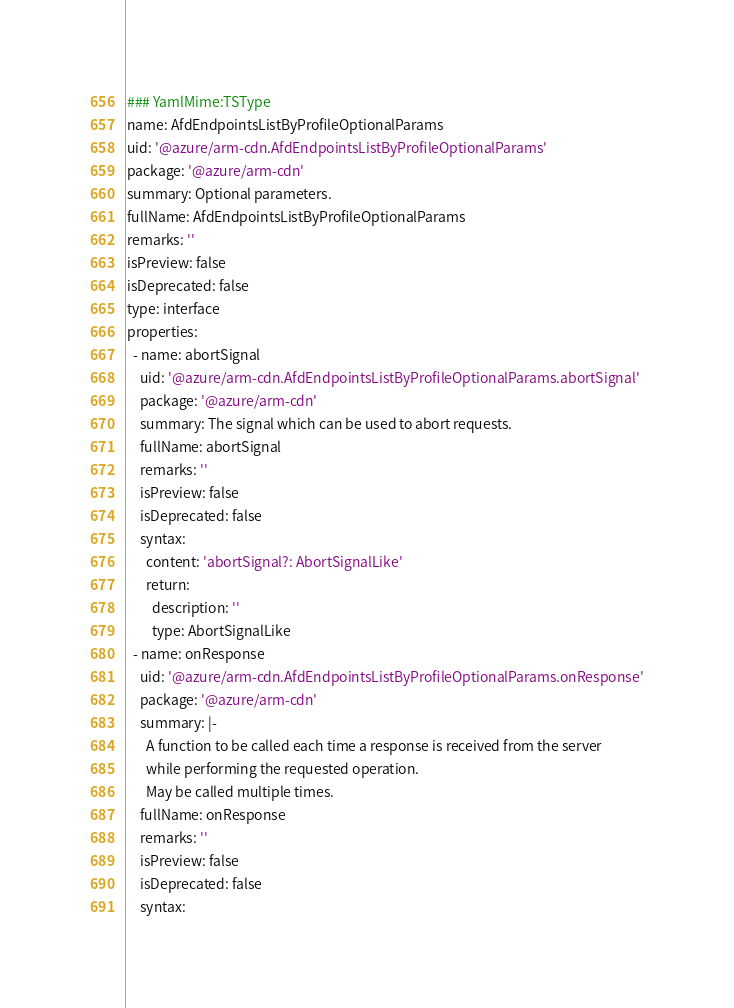Convert code to text. <code><loc_0><loc_0><loc_500><loc_500><_YAML_>### YamlMime:TSType
name: AfdEndpointsListByProfileOptionalParams
uid: '@azure/arm-cdn.AfdEndpointsListByProfileOptionalParams'
package: '@azure/arm-cdn'
summary: Optional parameters.
fullName: AfdEndpointsListByProfileOptionalParams
remarks: ''
isPreview: false
isDeprecated: false
type: interface
properties:
  - name: abortSignal
    uid: '@azure/arm-cdn.AfdEndpointsListByProfileOptionalParams.abortSignal'
    package: '@azure/arm-cdn'
    summary: The signal which can be used to abort requests.
    fullName: abortSignal
    remarks: ''
    isPreview: false
    isDeprecated: false
    syntax:
      content: 'abortSignal?: AbortSignalLike'
      return:
        description: ''
        type: AbortSignalLike
  - name: onResponse
    uid: '@azure/arm-cdn.AfdEndpointsListByProfileOptionalParams.onResponse'
    package: '@azure/arm-cdn'
    summary: |-
      A function to be called each time a response is received from the server
      while performing the requested operation.
      May be called multiple times.
    fullName: onResponse
    remarks: ''
    isPreview: false
    isDeprecated: false
    syntax:</code> 